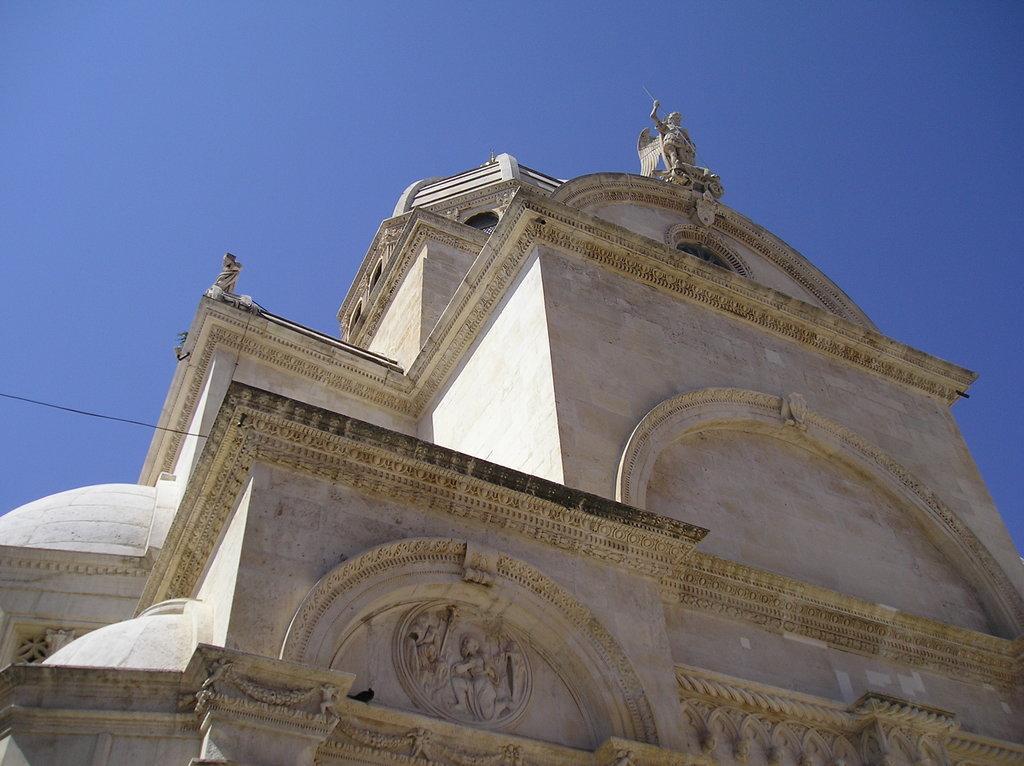Please provide a concise description of this image. In this image, we can see a building. There is a sky at the top of the image. There are sculptures on the building. 